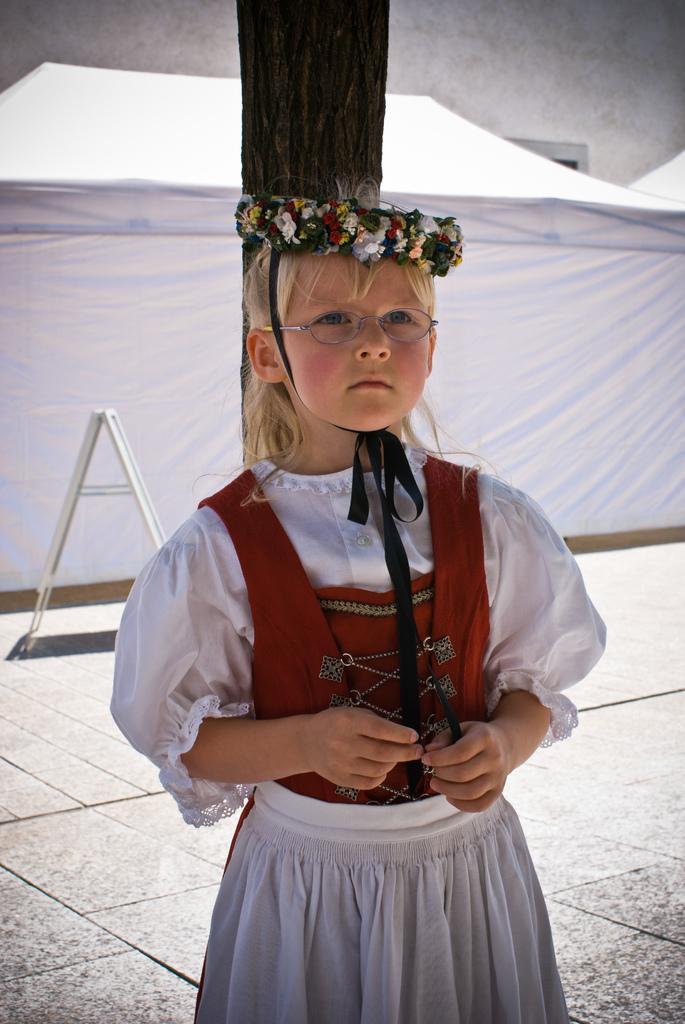Can you describe this image briefly? In the center of the image there is a girl on the floor. In the background we can see curtain and tree. 